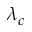Convert formula to latex. <formula><loc_0><loc_0><loc_500><loc_500>\lambda _ { c }</formula> 